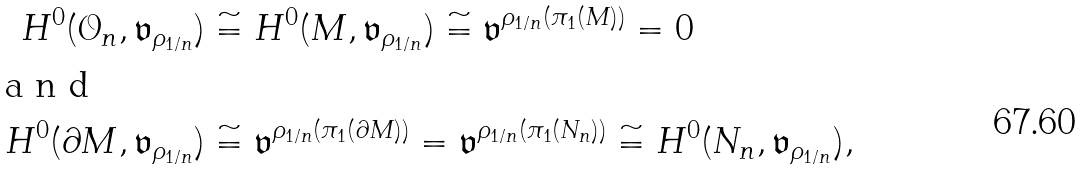<formula> <loc_0><loc_0><loc_500><loc_500>H ^ { 0 } ( { \mathcal { O } } _ { n } , \mathfrak { v } _ { \rho _ { 1 / n } } ) & \cong H ^ { 0 } ( M , \mathfrak { v } _ { \rho _ { 1 / n } } ) \cong \mathfrak { v } ^ { \rho _ { 1 / n } ( \pi _ { 1 } ( M ) ) } = 0 \\ \intertext { a n d } H ^ { 0 } ( \partial M , \mathfrak { v } _ { \rho _ { 1 / n } } ) & \cong \mathfrak { v } ^ { \rho _ { 1 / n } ( \pi _ { 1 } ( \partial M ) ) } = \mathfrak { v } ^ { \rho _ { 1 / n } ( \pi _ { 1 } ( N _ { n } ) ) } \cong H ^ { 0 } ( N _ { n } , \mathfrak { v } _ { \rho _ { 1 / n } } ) ,</formula> 